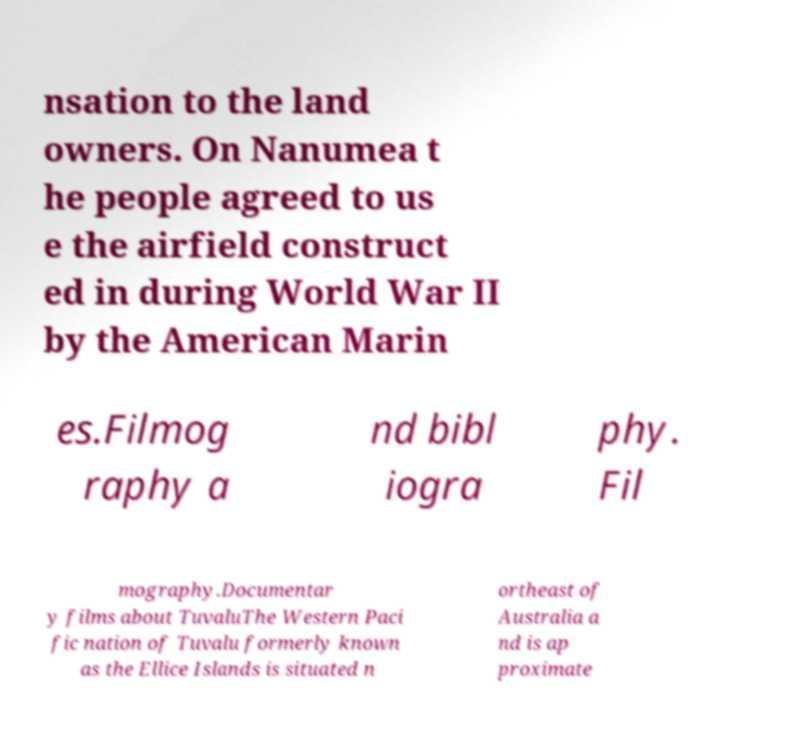There's text embedded in this image that I need extracted. Can you transcribe it verbatim? nsation to the land owners. On Nanumea t he people agreed to us e the airfield construct ed in during World War II by the American Marin es.Filmog raphy a nd bibl iogra phy. Fil mography.Documentar y films about TuvaluThe Western Paci fic nation of Tuvalu formerly known as the Ellice Islands is situated n ortheast of Australia a nd is ap proximate 